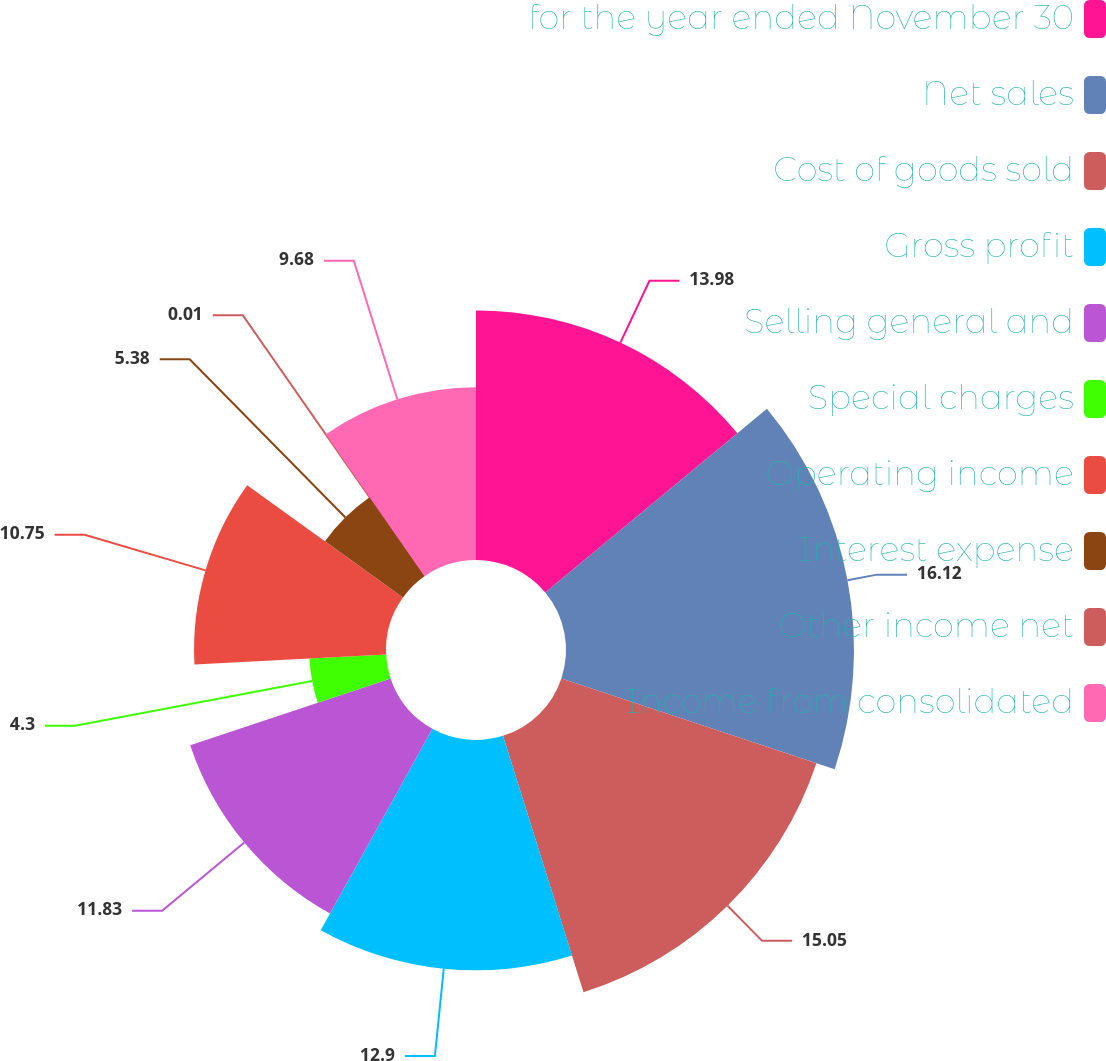<chart> <loc_0><loc_0><loc_500><loc_500><pie_chart><fcel>for the year ended November 30<fcel>Net sales<fcel>Cost of goods sold<fcel>Gross profit<fcel>Selling general and<fcel>Special charges<fcel>Operating income<fcel>Interest expense<fcel>Other income net<fcel>Income from consolidated<nl><fcel>13.98%<fcel>16.13%<fcel>15.05%<fcel>12.9%<fcel>11.83%<fcel>4.3%<fcel>10.75%<fcel>5.38%<fcel>0.01%<fcel>9.68%<nl></chart> 